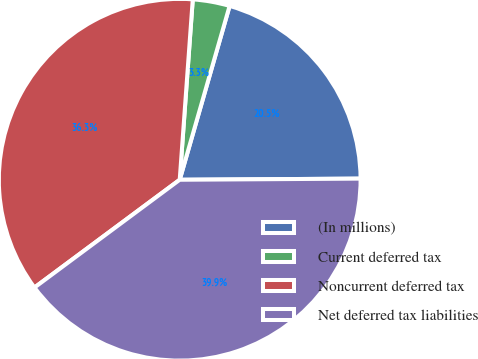<chart> <loc_0><loc_0><loc_500><loc_500><pie_chart><fcel>(In millions)<fcel>Current deferred tax<fcel>Noncurrent deferred tax<fcel>Net deferred tax liabilities<nl><fcel>20.45%<fcel>3.3%<fcel>36.31%<fcel>39.94%<nl></chart> 